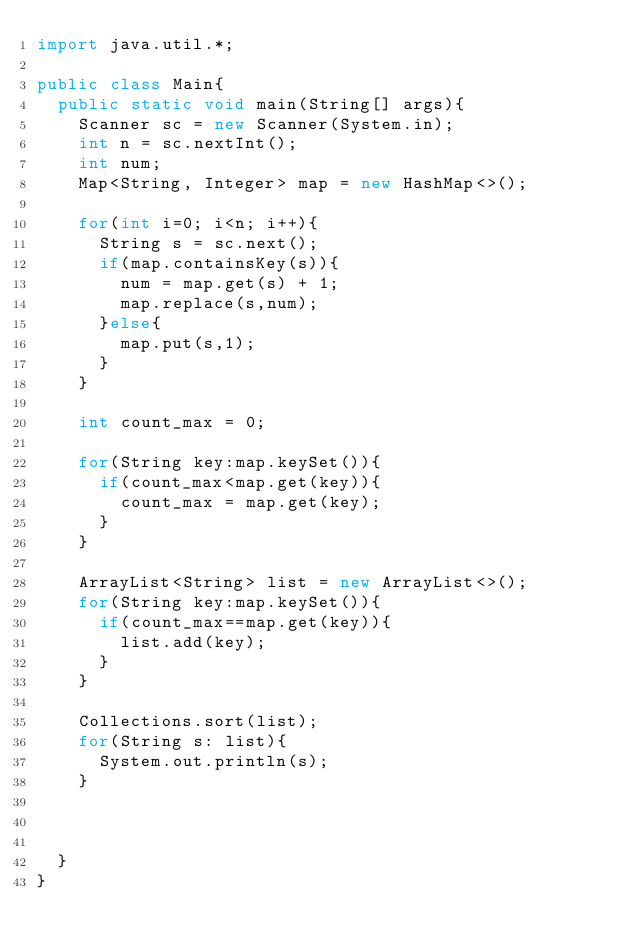<code> <loc_0><loc_0><loc_500><loc_500><_Java_>import java.util.*;

public class Main{
  public static void main(String[] args){
    Scanner sc = new Scanner(System.in);
    int n = sc.nextInt();
    int num;
    Map<String, Integer> map = new HashMap<>();

    for(int i=0; i<n; i++){
      String s = sc.next();
      if(map.containsKey(s)){
        num = map.get(s) + 1;
        map.replace(s,num);
      }else{
        map.put(s,1);
      }
    }

    int count_max = 0;

    for(String key:map.keySet()){
      if(count_max<map.get(key)){
        count_max = map.get(key);
      }
    }

    ArrayList<String> list = new ArrayList<>();
    for(String key:map.keySet()){
      if(count_max==map.get(key)){
        list.add(key);
      }
    }

    Collections.sort(list);
    for(String s: list){
      System.out.println(s);
    }



  }
}</code> 